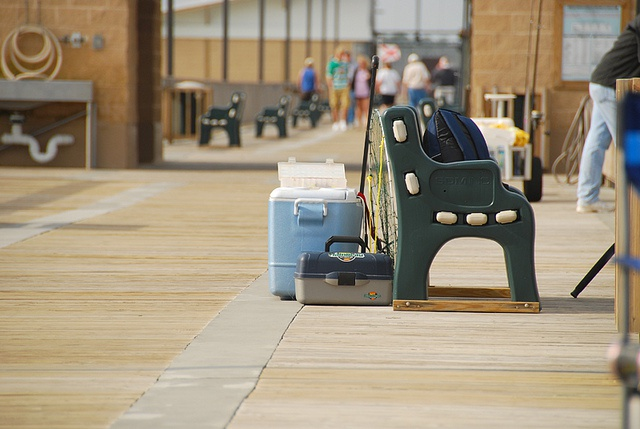Describe the objects in this image and their specific colors. I can see bench in olive, black, tan, and gray tones, suitcase in olive, gray, black, and darkgray tones, people in olive, black, darkgray, lightgray, and gray tones, backpack in olive, black, navy, gray, and blue tones, and sink in olive, gray, and black tones in this image. 